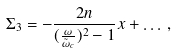<formula> <loc_0><loc_0><loc_500><loc_500>\Sigma _ { 3 } = - \frac { 2 n } { ( \frac { \omega } { \tilde { \omega } _ { c } } ) ^ { 2 } - 1 } x + \dots \, ,</formula> 